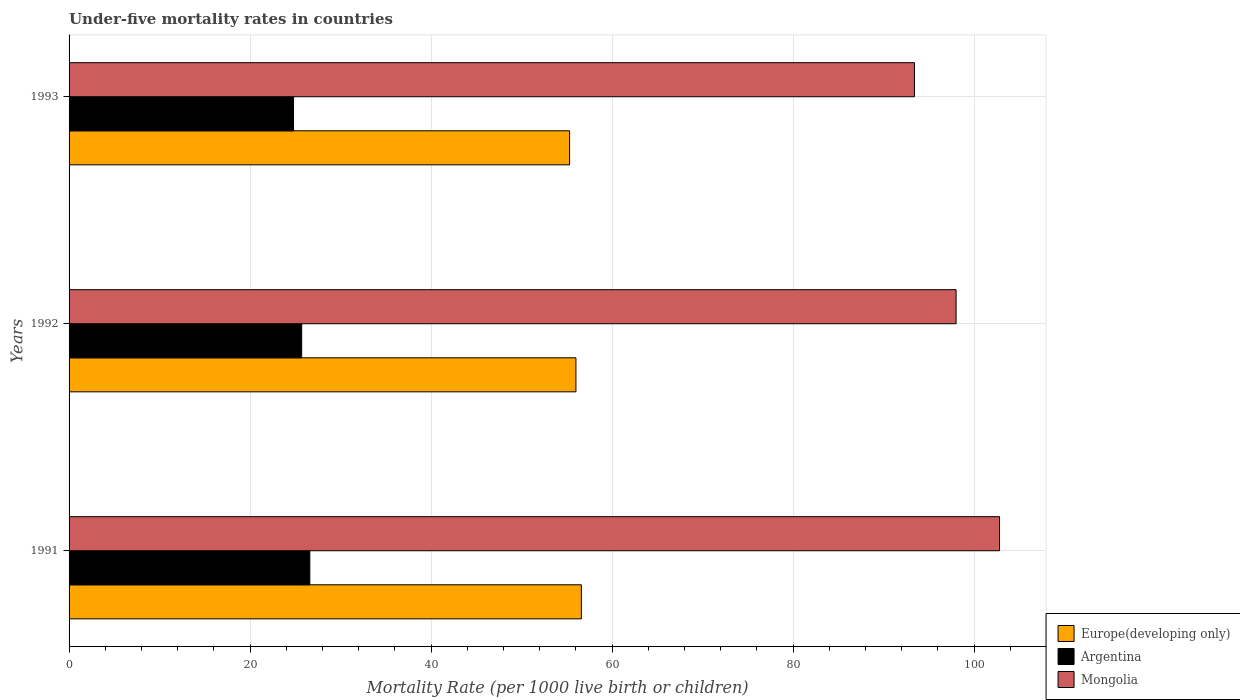How many different coloured bars are there?
Ensure brevity in your answer.  3. How many groups of bars are there?
Your response must be concise. 3. Are the number of bars per tick equal to the number of legend labels?
Provide a succinct answer. Yes. Are the number of bars on each tick of the Y-axis equal?
Offer a very short reply. Yes. What is the label of the 1st group of bars from the top?
Offer a terse response. 1993. In how many cases, is the number of bars for a given year not equal to the number of legend labels?
Provide a short and direct response. 0. What is the under-five mortality rate in Europe(developing only) in 1992?
Your answer should be compact. 56. Across all years, what is the maximum under-five mortality rate in Mongolia?
Offer a very short reply. 102.8. Across all years, what is the minimum under-five mortality rate in Argentina?
Provide a short and direct response. 24.8. In which year was the under-five mortality rate in Mongolia maximum?
Offer a terse response. 1991. What is the total under-five mortality rate in Mongolia in the graph?
Offer a terse response. 294.2. What is the difference between the under-five mortality rate in Europe(developing only) in 1991 and that in 1992?
Provide a short and direct response. 0.6. What is the difference between the under-five mortality rate in Europe(developing only) in 1993 and the under-five mortality rate in Argentina in 1991?
Keep it short and to the point. 28.7. What is the average under-five mortality rate in Mongolia per year?
Make the answer very short. 98.07. In the year 1991, what is the difference between the under-five mortality rate in Mongolia and under-five mortality rate in Argentina?
Ensure brevity in your answer.  76.2. In how many years, is the under-five mortality rate in Europe(developing only) greater than 80 ?
Offer a very short reply. 0. What is the ratio of the under-five mortality rate in Mongolia in 1991 to that in 1992?
Ensure brevity in your answer.  1.05. Is the under-five mortality rate in Argentina in 1991 less than that in 1992?
Provide a succinct answer. No. What is the difference between the highest and the second highest under-five mortality rate in Europe(developing only)?
Your response must be concise. 0.6. What is the difference between the highest and the lowest under-five mortality rate in Argentina?
Provide a succinct answer. 1.8. Is the sum of the under-five mortality rate in Mongolia in 1991 and 1992 greater than the maximum under-five mortality rate in Europe(developing only) across all years?
Provide a succinct answer. Yes. What does the 3rd bar from the top in 1992 represents?
Ensure brevity in your answer.  Europe(developing only). How many legend labels are there?
Provide a succinct answer. 3. How are the legend labels stacked?
Your response must be concise. Vertical. What is the title of the graph?
Keep it short and to the point. Under-five mortality rates in countries. Does "Swaziland" appear as one of the legend labels in the graph?
Provide a succinct answer. No. What is the label or title of the X-axis?
Give a very brief answer. Mortality Rate (per 1000 live birth or children). What is the Mortality Rate (per 1000 live birth or children) in Europe(developing only) in 1991?
Provide a short and direct response. 56.6. What is the Mortality Rate (per 1000 live birth or children) in Argentina in 1991?
Your answer should be compact. 26.6. What is the Mortality Rate (per 1000 live birth or children) in Mongolia in 1991?
Offer a very short reply. 102.8. What is the Mortality Rate (per 1000 live birth or children) in Europe(developing only) in 1992?
Your answer should be compact. 56. What is the Mortality Rate (per 1000 live birth or children) of Argentina in 1992?
Ensure brevity in your answer.  25.7. What is the Mortality Rate (per 1000 live birth or children) of Europe(developing only) in 1993?
Keep it short and to the point. 55.3. What is the Mortality Rate (per 1000 live birth or children) in Argentina in 1993?
Offer a terse response. 24.8. What is the Mortality Rate (per 1000 live birth or children) of Mongolia in 1993?
Keep it short and to the point. 93.4. Across all years, what is the maximum Mortality Rate (per 1000 live birth or children) in Europe(developing only)?
Keep it short and to the point. 56.6. Across all years, what is the maximum Mortality Rate (per 1000 live birth or children) of Argentina?
Your response must be concise. 26.6. Across all years, what is the maximum Mortality Rate (per 1000 live birth or children) of Mongolia?
Provide a short and direct response. 102.8. Across all years, what is the minimum Mortality Rate (per 1000 live birth or children) in Europe(developing only)?
Provide a short and direct response. 55.3. Across all years, what is the minimum Mortality Rate (per 1000 live birth or children) of Argentina?
Keep it short and to the point. 24.8. Across all years, what is the minimum Mortality Rate (per 1000 live birth or children) in Mongolia?
Your answer should be compact. 93.4. What is the total Mortality Rate (per 1000 live birth or children) of Europe(developing only) in the graph?
Give a very brief answer. 167.9. What is the total Mortality Rate (per 1000 live birth or children) in Argentina in the graph?
Offer a terse response. 77.1. What is the total Mortality Rate (per 1000 live birth or children) of Mongolia in the graph?
Your answer should be compact. 294.2. What is the difference between the Mortality Rate (per 1000 live birth or children) of Argentina in 1991 and that in 1992?
Your answer should be compact. 0.9. What is the difference between the Mortality Rate (per 1000 live birth or children) of Mongolia in 1991 and that in 1992?
Provide a short and direct response. 4.8. What is the difference between the Mortality Rate (per 1000 live birth or children) in Argentina in 1991 and that in 1993?
Offer a very short reply. 1.8. What is the difference between the Mortality Rate (per 1000 live birth or children) in Argentina in 1992 and that in 1993?
Offer a very short reply. 0.9. What is the difference between the Mortality Rate (per 1000 live birth or children) in Mongolia in 1992 and that in 1993?
Give a very brief answer. 4.6. What is the difference between the Mortality Rate (per 1000 live birth or children) of Europe(developing only) in 1991 and the Mortality Rate (per 1000 live birth or children) of Argentina in 1992?
Provide a short and direct response. 30.9. What is the difference between the Mortality Rate (per 1000 live birth or children) of Europe(developing only) in 1991 and the Mortality Rate (per 1000 live birth or children) of Mongolia in 1992?
Offer a terse response. -41.4. What is the difference between the Mortality Rate (per 1000 live birth or children) in Argentina in 1991 and the Mortality Rate (per 1000 live birth or children) in Mongolia in 1992?
Offer a very short reply. -71.4. What is the difference between the Mortality Rate (per 1000 live birth or children) in Europe(developing only) in 1991 and the Mortality Rate (per 1000 live birth or children) in Argentina in 1993?
Your answer should be compact. 31.8. What is the difference between the Mortality Rate (per 1000 live birth or children) in Europe(developing only) in 1991 and the Mortality Rate (per 1000 live birth or children) in Mongolia in 1993?
Your response must be concise. -36.8. What is the difference between the Mortality Rate (per 1000 live birth or children) of Argentina in 1991 and the Mortality Rate (per 1000 live birth or children) of Mongolia in 1993?
Offer a terse response. -66.8. What is the difference between the Mortality Rate (per 1000 live birth or children) of Europe(developing only) in 1992 and the Mortality Rate (per 1000 live birth or children) of Argentina in 1993?
Your answer should be very brief. 31.2. What is the difference between the Mortality Rate (per 1000 live birth or children) in Europe(developing only) in 1992 and the Mortality Rate (per 1000 live birth or children) in Mongolia in 1993?
Your response must be concise. -37.4. What is the difference between the Mortality Rate (per 1000 live birth or children) of Argentina in 1992 and the Mortality Rate (per 1000 live birth or children) of Mongolia in 1993?
Ensure brevity in your answer.  -67.7. What is the average Mortality Rate (per 1000 live birth or children) in Europe(developing only) per year?
Ensure brevity in your answer.  55.97. What is the average Mortality Rate (per 1000 live birth or children) of Argentina per year?
Make the answer very short. 25.7. What is the average Mortality Rate (per 1000 live birth or children) of Mongolia per year?
Your answer should be very brief. 98.07. In the year 1991, what is the difference between the Mortality Rate (per 1000 live birth or children) in Europe(developing only) and Mortality Rate (per 1000 live birth or children) in Mongolia?
Your answer should be very brief. -46.2. In the year 1991, what is the difference between the Mortality Rate (per 1000 live birth or children) in Argentina and Mortality Rate (per 1000 live birth or children) in Mongolia?
Give a very brief answer. -76.2. In the year 1992, what is the difference between the Mortality Rate (per 1000 live birth or children) in Europe(developing only) and Mortality Rate (per 1000 live birth or children) in Argentina?
Offer a very short reply. 30.3. In the year 1992, what is the difference between the Mortality Rate (per 1000 live birth or children) of Europe(developing only) and Mortality Rate (per 1000 live birth or children) of Mongolia?
Offer a terse response. -42. In the year 1992, what is the difference between the Mortality Rate (per 1000 live birth or children) in Argentina and Mortality Rate (per 1000 live birth or children) in Mongolia?
Your answer should be compact. -72.3. In the year 1993, what is the difference between the Mortality Rate (per 1000 live birth or children) of Europe(developing only) and Mortality Rate (per 1000 live birth or children) of Argentina?
Your answer should be very brief. 30.5. In the year 1993, what is the difference between the Mortality Rate (per 1000 live birth or children) of Europe(developing only) and Mortality Rate (per 1000 live birth or children) of Mongolia?
Make the answer very short. -38.1. In the year 1993, what is the difference between the Mortality Rate (per 1000 live birth or children) of Argentina and Mortality Rate (per 1000 live birth or children) of Mongolia?
Your answer should be compact. -68.6. What is the ratio of the Mortality Rate (per 1000 live birth or children) in Europe(developing only) in 1991 to that in 1992?
Make the answer very short. 1.01. What is the ratio of the Mortality Rate (per 1000 live birth or children) in Argentina in 1991 to that in 1992?
Provide a short and direct response. 1.03. What is the ratio of the Mortality Rate (per 1000 live birth or children) in Mongolia in 1991 to that in 1992?
Give a very brief answer. 1.05. What is the ratio of the Mortality Rate (per 1000 live birth or children) in Europe(developing only) in 1991 to that in 1993?
Your response must be concise. 1.02. What is the ratio of the Mortality Rate (per 1000 live birth or children) in Argentina in 1991 to that in 1993?
Your answer should be very brief. 1.07. What is the ratio of the Mortality Rate (per 1000 live birth or children) of Mongolia in 1991 to that in 1993?
Your response must be concise. 1.1. What is the ratio of the Mortality Rate (per 1000 live birth or children) in Europe(developing only) in 1992 to that in 1993?
Make the answer very short. 1.01. What is the ratio of the Mortality Rate (per 1000 live birth or children) in Argentina in 1992 to that in 1993?
Keep it short and to the point. 1.04. What is the ratio of the Mortality Rate (per 1000 live birth or children) of Mongolia in 1992 to that in 1993?
Give a very brief answer. 1.05. What is the difference between the highest and the second highest Mortality Rate (per 1000 live birth or children) in Europe(developing only)?
Your answer should be compact. 0.6. 